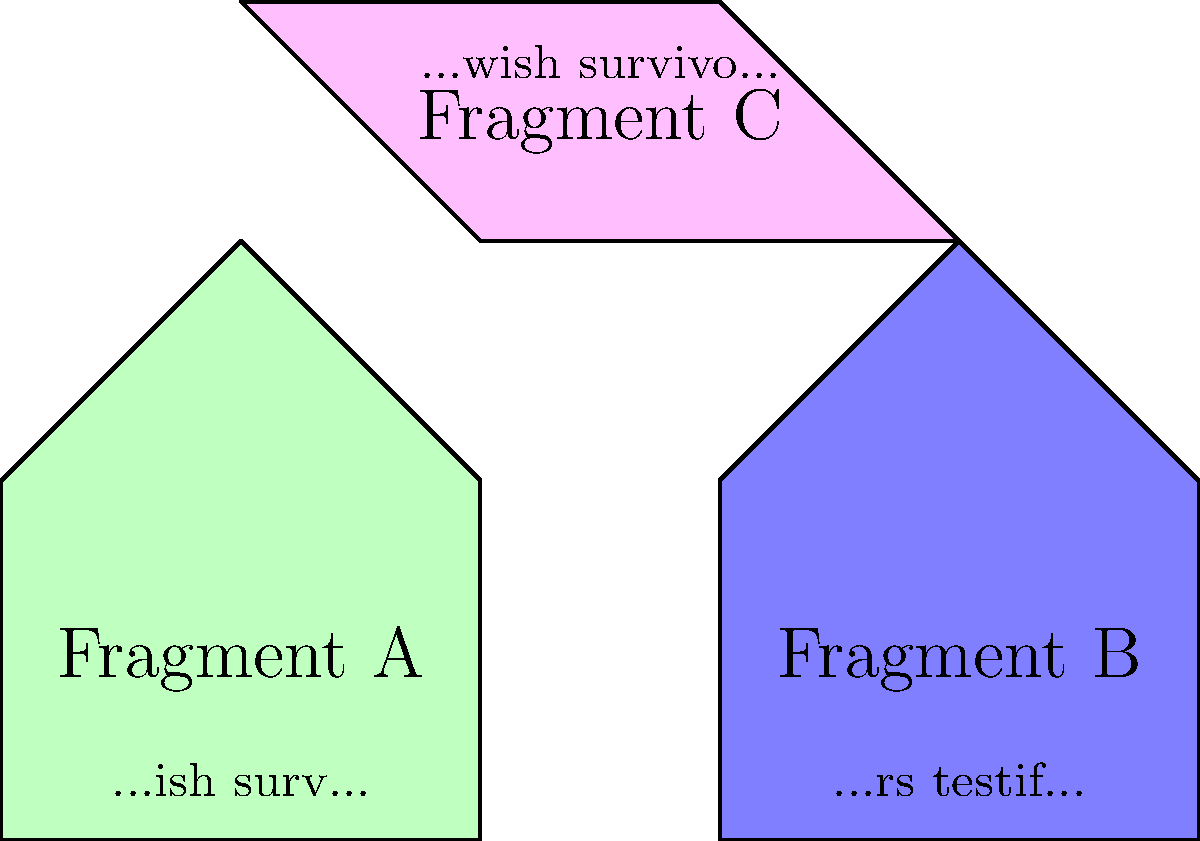Based on the shapes and partial text of the document fragments shown in the diagram, what is the most likely complete phrase that can be reconstructed from these pieces? To reconstruct the complete phrase, we need to follow these steps:

1. Analyze the shapes of the fragments:
   - Fragment A (green) and Fragment B (blue) appear to form the bottom part of the document.
   - Fragment C (pink) seems to be the top part that connects A and B.

2. Examine the partial text on each fragment:
   - Fragment A: "...ish surv..."
   - Fragment B: "...rs testif..."
   - Fragment C: "...wish survivo..."

3. Align the fragments based on their shapes and text:
   - Fragment C's "...wish survivo..." aligns with Fragment A's "...ish surv..."
   - The remaining part of Fragment B "...rs testif..." likely follows the text from A and C.

4. Reconstruct the complete phrase:
   - The beginning of the phrase is clearly "Jewish survivo..."
   - The logical completion of "survivo..." is "survivors"
   - The end of the phrase is "...rs testif..."
   - The most likely word to complete the phrase is "testify"

5. Combine all parts to form the complete phrase:
   "Jewish survivors testify"

This reconstructed phrase is consistent with the content that an archivist working on Holocaust-related documents might encounter, as it refers to Jewish survivors giving testimony about their experiences.
Answer: Jewish survivors testify 